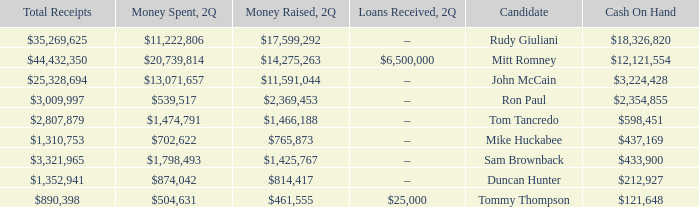Tell me the money raised when 2Q has total receipts of $890,398 $461,555. 